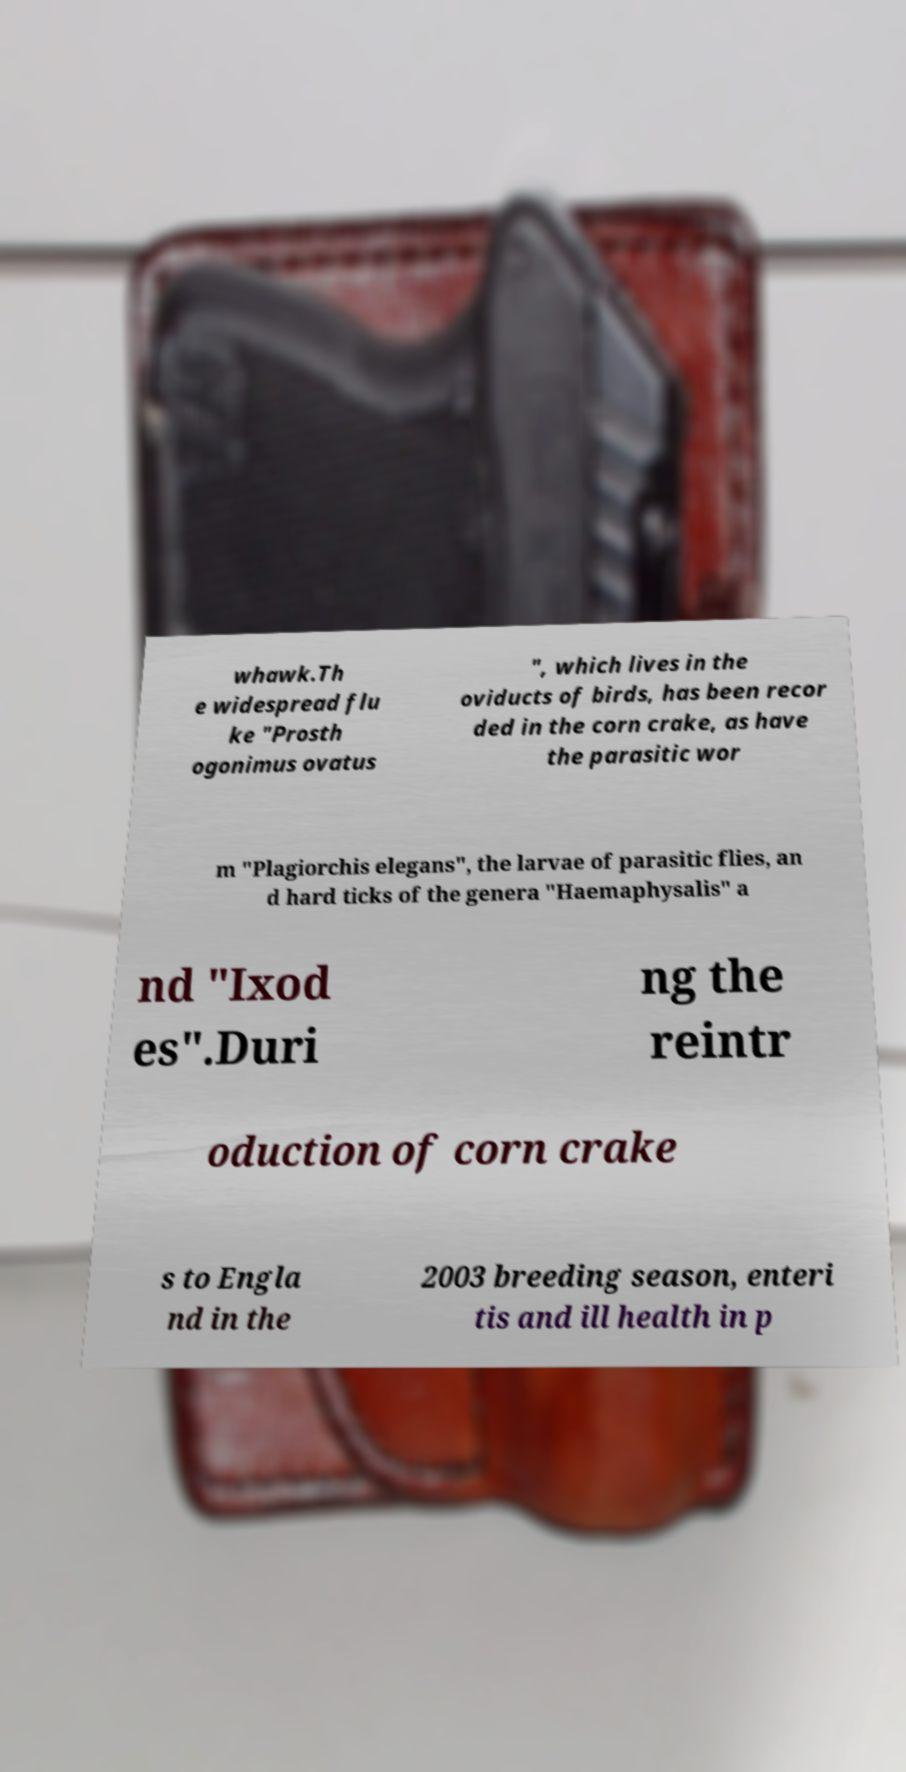Can you accurately transcribe the text from the provided image for me? whawk.Th e widespread flu ke "Prosth ogonimus ovatus ", which lives in the oviducts of birds, has been recor ded in the corn crake, as have the parasitic wor m "Plagiorchis elegans", the larvae of parasitic flies, an d hard ticks of the genera "Haemaphysalis" a nd "Ixod es".Duri ng the reintr oduction of corn crake s to Engla nd in the 2003 breeding season, enteri tis and ill health in p 